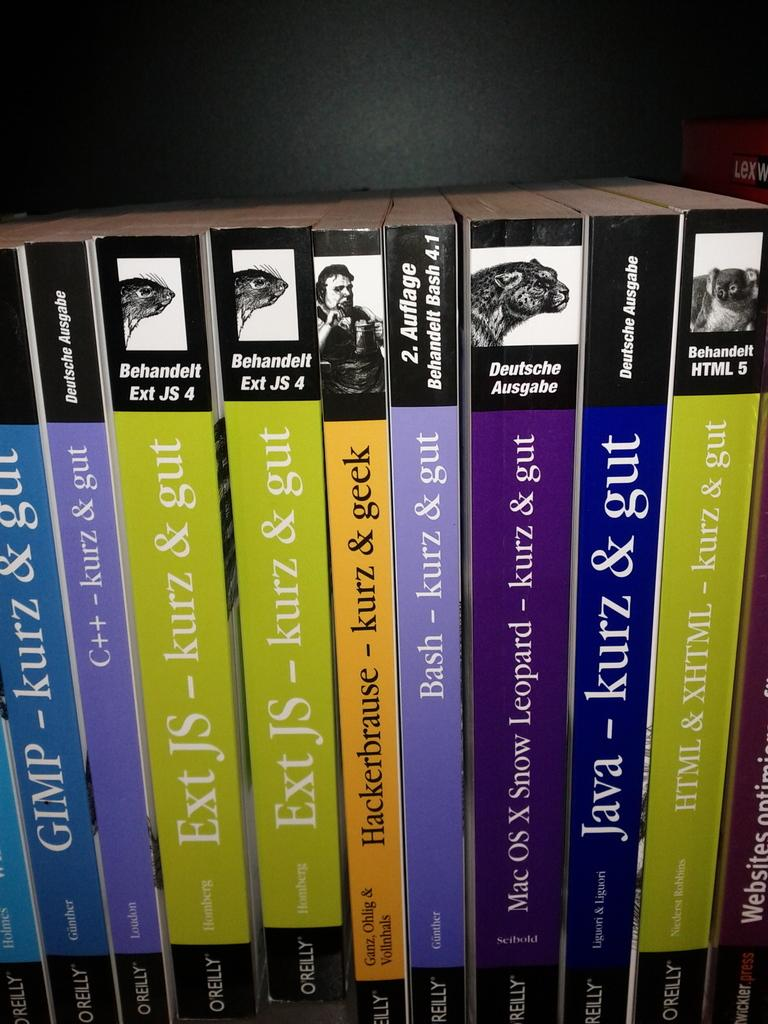<image>
Present a compact description of the photo's key features. Several books stacked together are by Kurz & Gut 